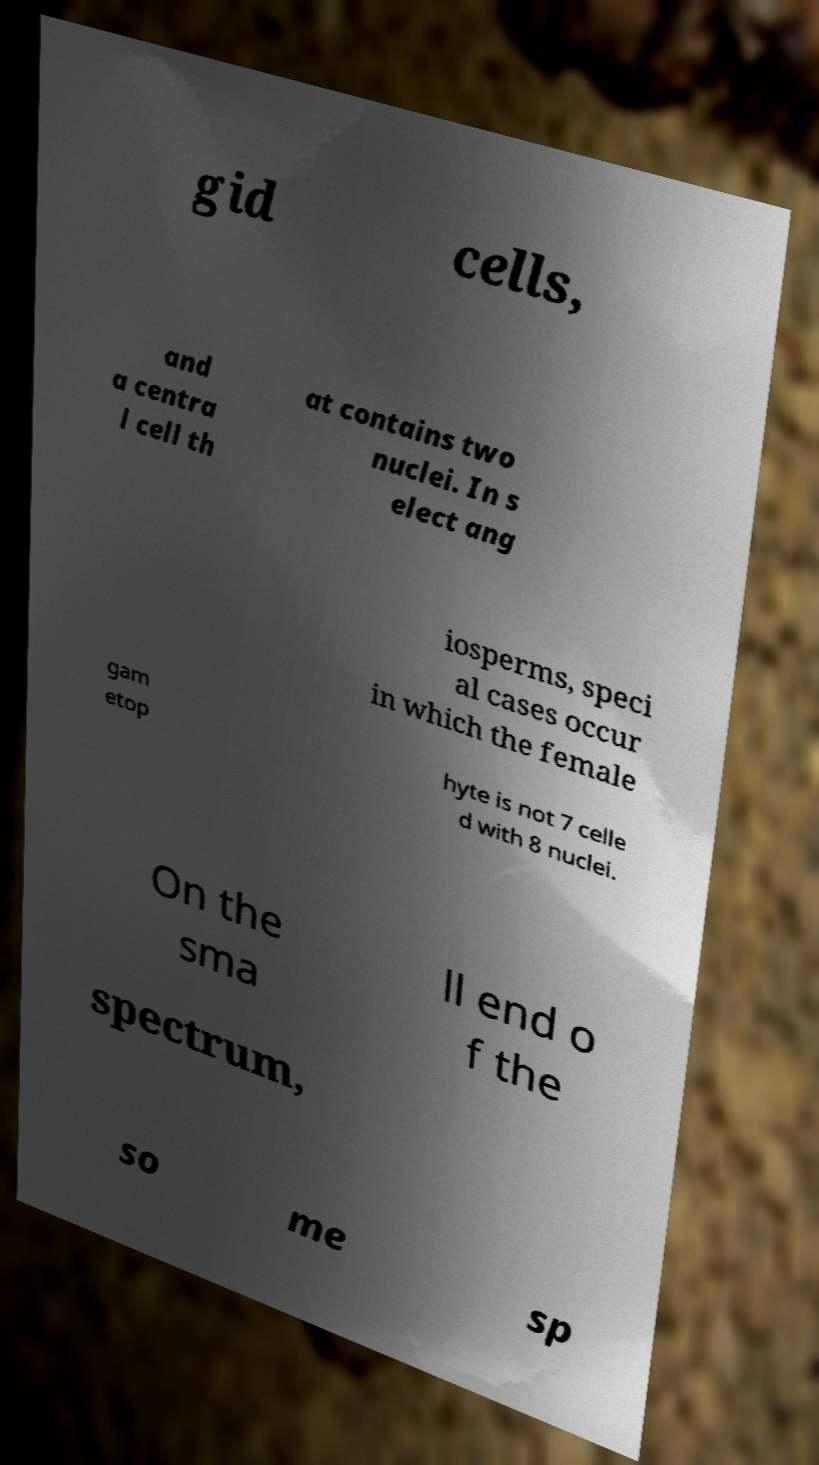Could you assist in decoding the text presented in this image and type it out clearly? gid cells, and a centra l cell th at contains two nuclei. In s elect ang iosperms, speci al cases occur in which the female gam etop hyte is not 7 celle d with 8 nuclei. On the sma ll end o f the spectrum, so me sp 